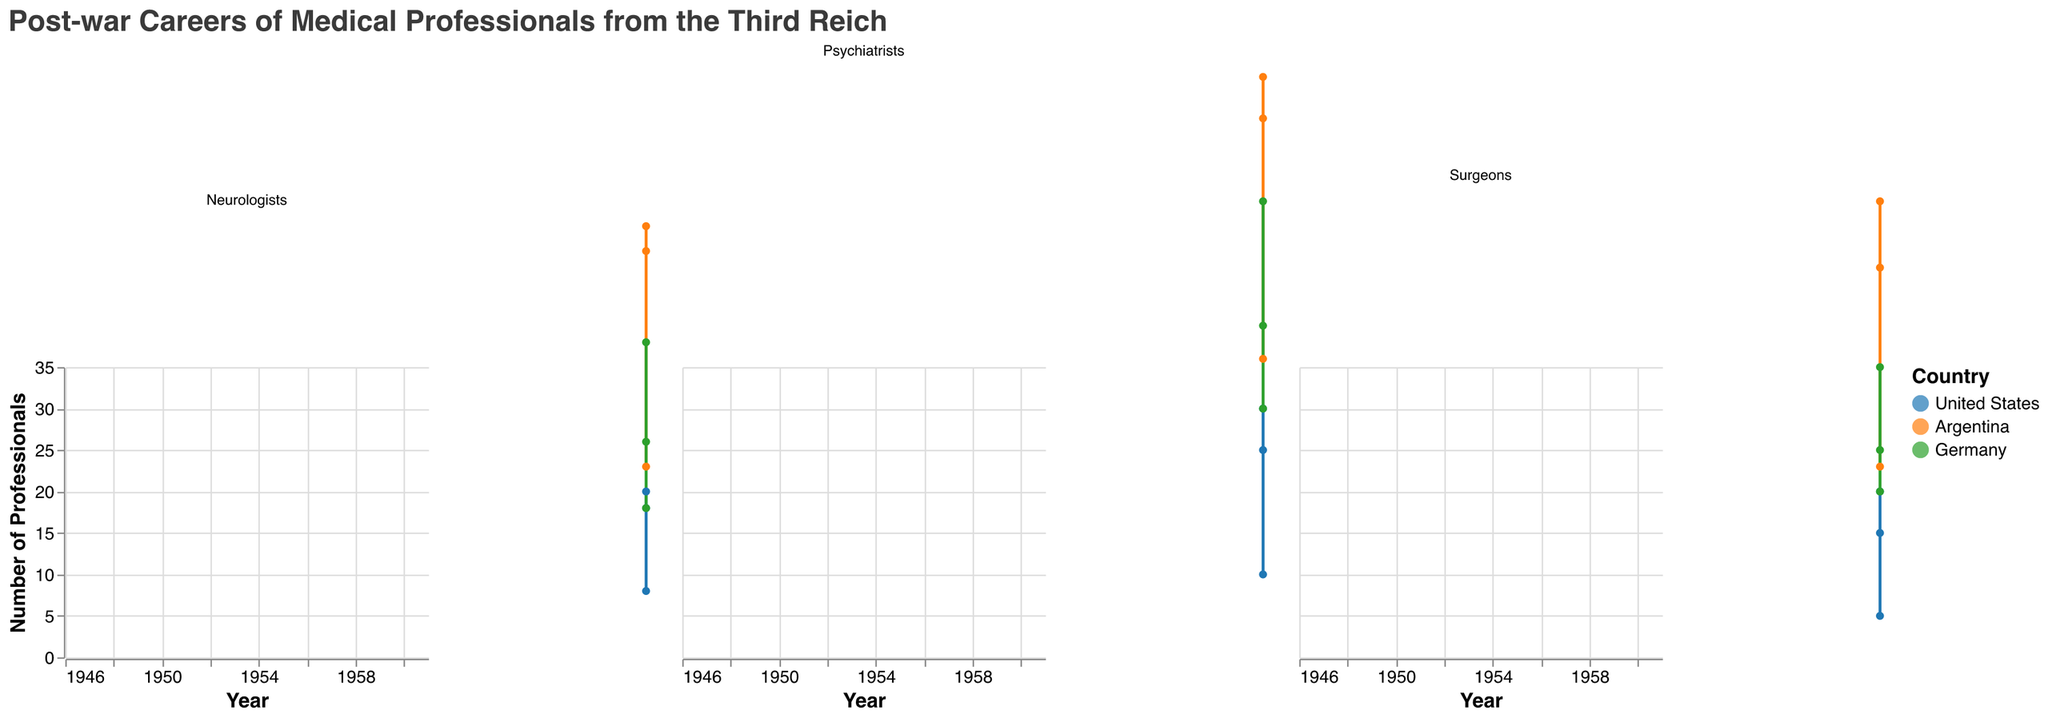What is the title of the figure? The title is located at the top of the figure and provides an overview of the content being presented.
Answer: Post-war Careers of Medical Professionals from the Third Reich How many subplots are there in the figure? Each subplot corresponds to a specialization. The figure consists of three specializations: Surgeons, Psychiatrists, and Neurologists.
Answer: 3 Which country saw the highest number of Surgeons in 1960? Across the Surgeons subplot, the area chart for Argentina in 1960 reaches its peak value compared to the United States and Germany.
Answer: Argentina What is the total number of Psychiatrists in Germany across all the years? Sum up the count of Psychiatrists in Germany for each year: 20 (1946) + 30 (1950) + 10 (1960).
Answer: 60 Between 1946 and 1960, which specialization saw the most significant increase in the United States? By examining the slope of the area chart lines for each specialization, Psychiatrists have the steepest increase, from 10 in 1946 to 30 in 1960.
Answer: Psychiatrists Compare the count of Neurologists in Argentina and Germany in 1950. Which country had fewer? In 1950, Argentina had 14 Neurologists, and Germany had 18. Thus, Argentina had fewer Neurologists than Germany in 1950.
Answer: Argentina What was the total number of medical professionals in Argentina in 1946? Sum up the number of Surgeons, Psychiatrists, and Neurologists in Argentina in 1946, which are 3, 6, and 5 respectively. 3 + 6 + 5 = 14.
Answer: 14 Which specialization saw the highest number of professionals in the United States in 1950? Among the specializations, Psychiatrists reached 25 in the United States in 1950, which is higher compared to Surgeons (15) and Neurologists (20).
Answer: Psychiatrists How did the number of Surgeons in Germany change from 1950 to 1960? From the data, Surgeons in Germany decreased from 20 in 1950 to 5 in 1960. This is a decrement of 15.
Answer: Decreased by 15 Which specialization has a similar trend line in the United States and Argentina from 1946 to 1960? Both the Surgeons and Psychiatrists specializations show an increasing trend from 1946 to 1960 in both the United States and Argentina.
Answer: Surgeons, Psychiatrists 